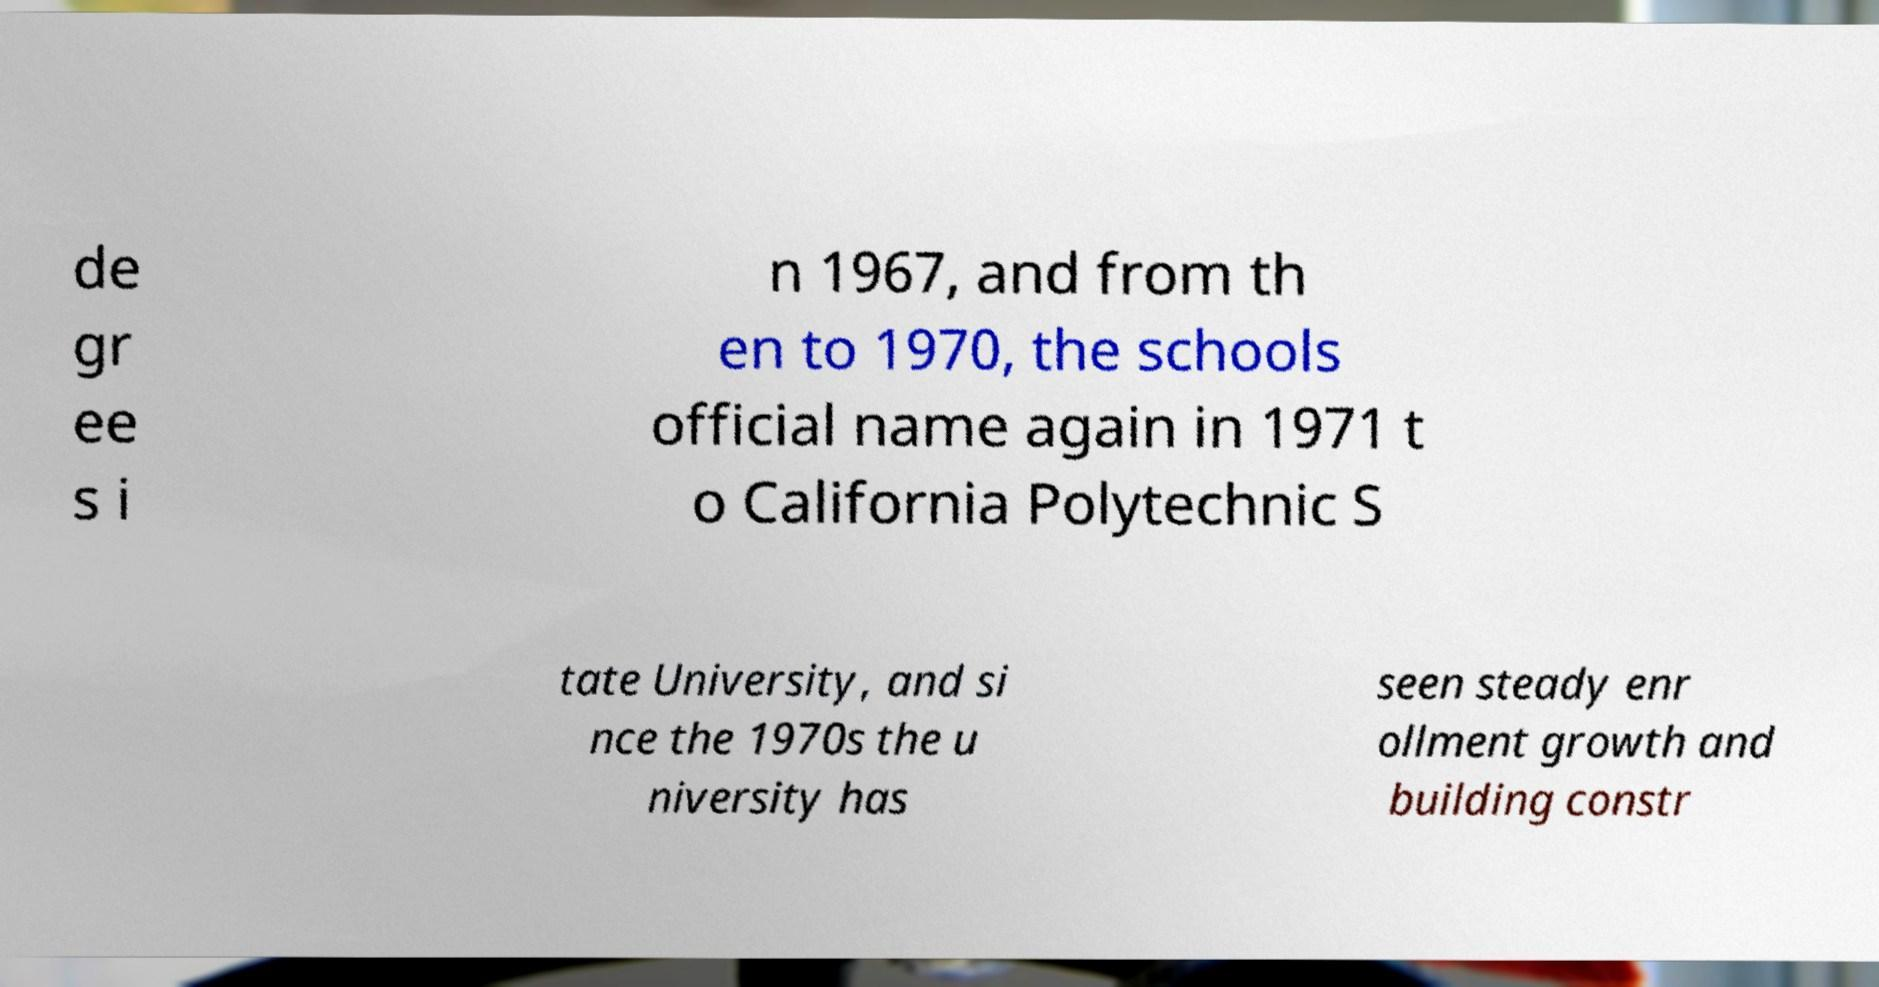Could you extract and type out the text from this image? de gr ee s i n 1967, and from th en to 1970, the schools official name again in 1971 t o California Polytechnic S tate University, and si nce the 1970s the u niversity has seen steady enr ollment growth and building constr 